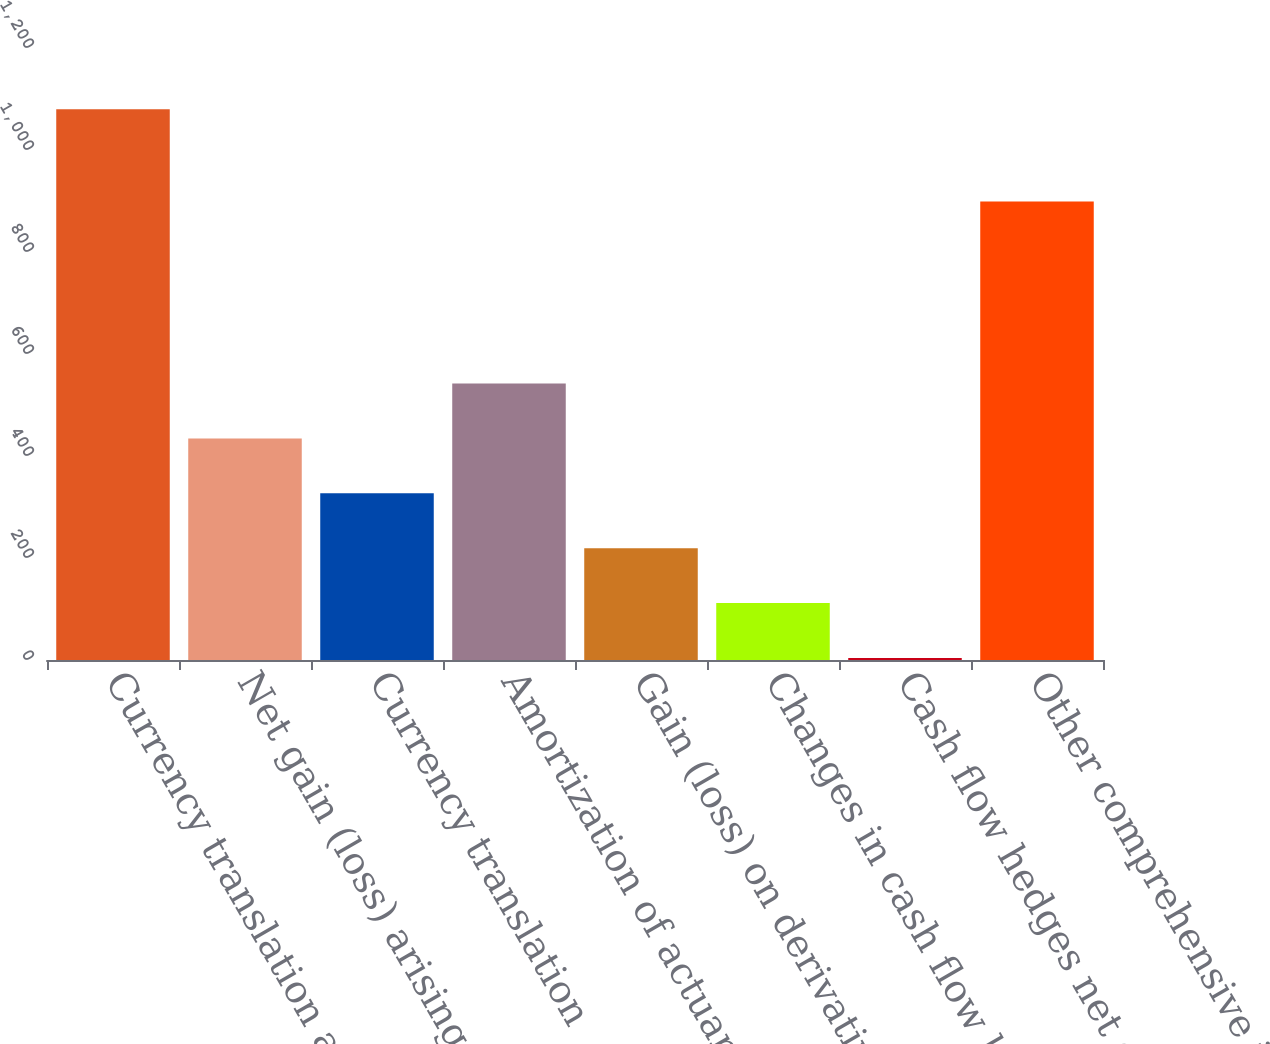Convert chart. <chart><loc_0><loc_0><loc_500><loc_500><bar_chart><fcel>Currency translation and<fcel>Net gain (loss) arising during<fcel>Currency translation<fcel>Amortization of actuarial loss<fcel>Gain (loss) on derivatives<fcel>Changes in cash flow hedges<fcel>Cash flow hedges net of<fcel>Other comprehensive income<nl><fcel>1080<fcel>434.4<fcel>326.8<fcel>542<fcel>219.2<fcel>111.6<fcel>4<fcel>899<nl></chart> 